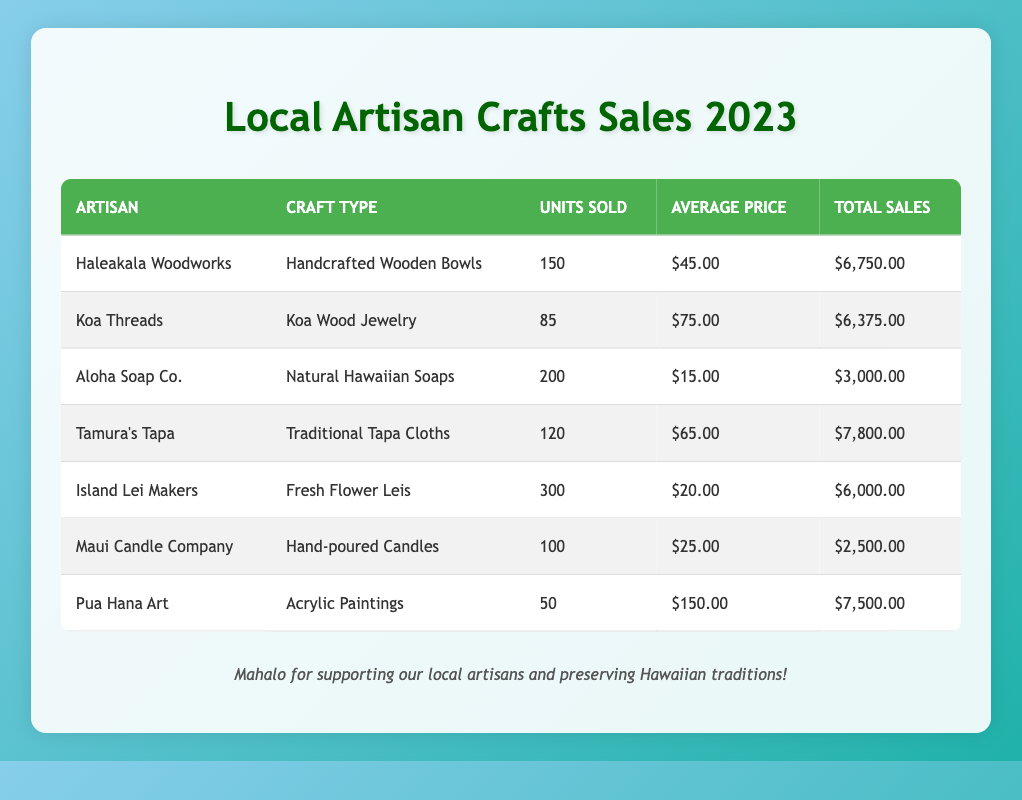What craft type sold the most units? Looking at the "Units Sold" column, the craft type with the highest value is "Fresh Flower Leis" which has 300 units sold.
Answer: Fresh Flower Leis Which artisan made the highest total sales? In the "Total Sales" column, the highest value is 7800.00, which corresponds to "Tamura's Tapa".
Answer: Tamura's Tapa What is the average price for "Koa Wood Jewelry"? The table shows "Koa Wood Jewelry" has an average price of 75.00, which can be directly found in the "Average Price" column for Koa Threads.
Answer: 75.00 Which two artisans had total sales greater than 6000.00? By comparing the "Total Sales" values, Haleakala Woodworks with 6750.00 and Tamura's Tapa with 7800.00 are the only artisans that exceeded 6000.00.
Answer: Haleakala Woodworks and Tamura's Tapa Is the average price of "Hand-poured Candles" less than that of "Acrylic Paintings"? "Hand-poured Candles" has an average price of 25.00, while "Acrylic Paintings" has an average price of 150.00. Since 25.00 is less than 150.00, the answer is yes.
Answer: Yes What is the total number of units sold for all crafts combined? Summing the units sold: 150 + 85 + 200 + 120 + 300 + 100 + 50 = 1005 units sold in total across all artisans.
Answer: 1005 What is the difference between the total sales of "Aloha Soap Co." and "Maui Candle Company"? The total sales of Aloha Soap Co. is 3000.00 and that of Maui Candle Company is 2500.00. Therefore, the difference is 3000.00 - 2500.00 = 500.00.
Answer: 500.00 Who sold the least number of units and how many? Checking the "Units Sold" column, "Acrylic Paintings" by Pua Hana Art sold the least with 50 units.
Answer: Pua Hana Art, 50 units What is the total sales of "Natural Hawaiian Soaps" compared to "Fresh Flower Leis"? "Natural Hawaiian Soaps" has total sales of 3000.00, while "Fresh Flower Leis" has total sales of 6000.00. Comparing these, Fresh Flower Leis has double the sales of Natural Hawaiian Soaps.
Answer: Fresh Flower Leis has double the sales 